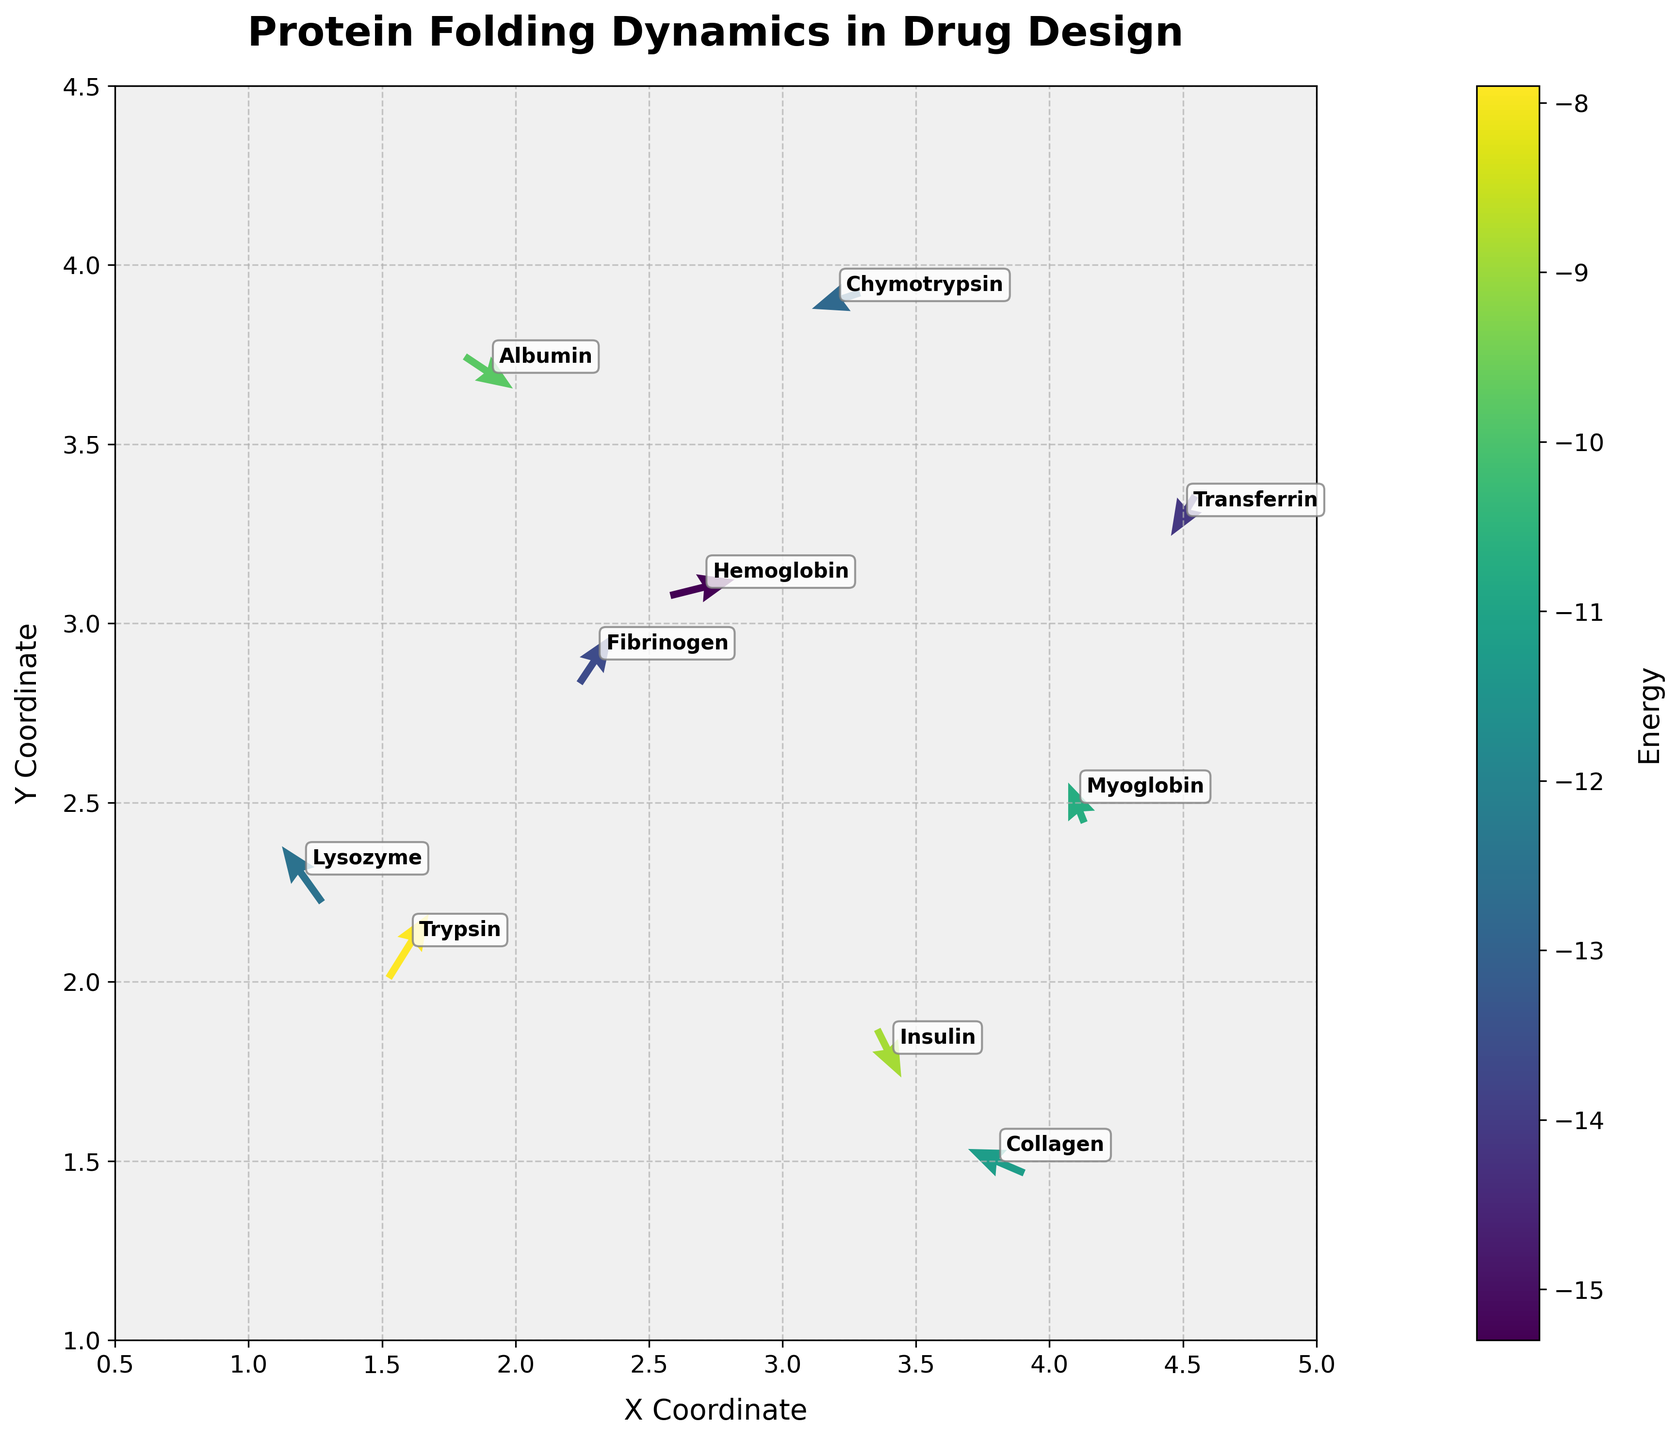What's the title of the figure? The title is usually found at the top of the figure. Here it says "Protein Folding Dynamics in Drug Design".
Answer: Protein Folding Dynamics in Drug Design What are the x and y axis labels? Axis labels are provided along the respective axes. The x-axis is labeled "X Coordinate" and the y-axis is labeled "Y Coordinate".
Answer: X Coordinate, Y Coordinate How many protein data points are illustrated in the figure? Each protein label represents a data point. Counting the annotations gives us 10 data points.
Answer: 10 Which protein has the highest energy value? The color of the arrows is scaled with energy. By looking at the color bar, the lightest color corresponds to the highest energy. "Trypsin" is annotated with the lightest color.
Answer: Trypsin What's the protein with the largest magnitude of velocity vector? The length of the vectors represents their magnitude. "Hemoglobin" has the longest arrow.
Answer: Hemoglobin How does the energy of Collagen compare to Albumin? Compare the colors of the two arrows using the color bar. Collagen's arrow has a slightly darker color indicating lower energy compared to Albumin.
Answer: Lower Which proteins have a negative y-component in their velocity? The y-components are the 'v' values for each protein. A negative y-component means the arrow points downwards. Insulin, Albumin, Transferrin, and Chymotrypsin have downward pointing arrows.
Answer: Insulin, Albumin, Transferrin, Chymotrypsin What is the net x-displacement of all proteins? Sum all the x-components 'u'. Σu = -0.5 + 0.3 + 0.8 - 0.2 + 0.6 - 0.7 + 0.4 - 0.3 + 0.5 - 0.6 = 0.3
Answer: 0.3 Which protein is located closest to the point (3, 2)? Compare the Euclidean distances to (3,2). Distances are different for each protein and need calculation: sqrt((3.4-3)^2 + (1.8-2)^2) is the smallest, giving "Insulin".
Answer: Insulin 